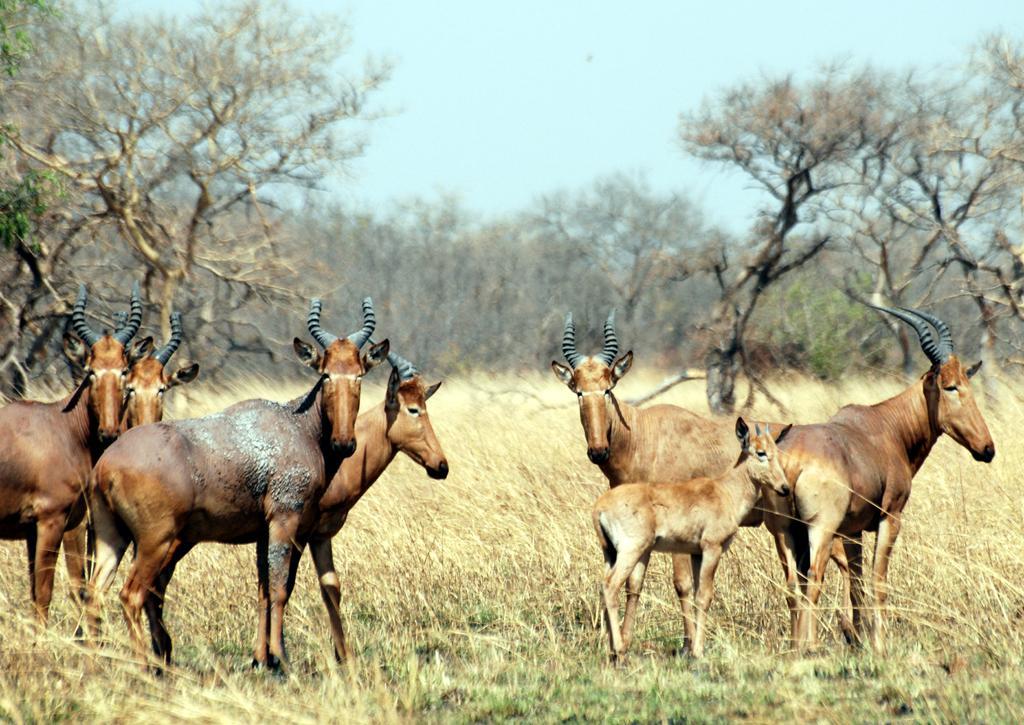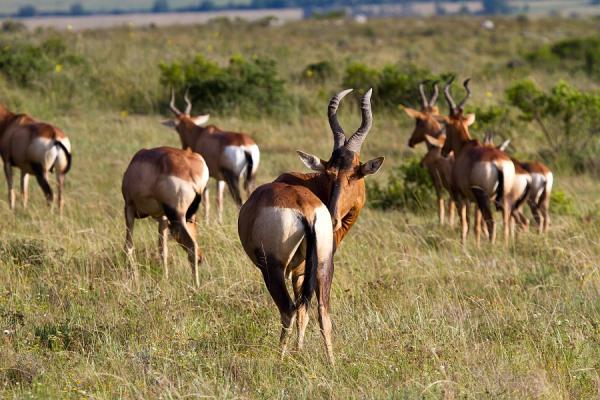The first image is the image on the left, the second image is the image on the right. Examine the images to the left and right. Is the description "One of the images contains no more than four antelopes" accurate? Answer yes or no. No. The first image is the image on the left, the second image is the image on the right. Evaluate the accuracy of this statement regarding the images: "All the horned animals in one image have their rears turned to the camera.". Is it true? Answer yes or no. Yes. 